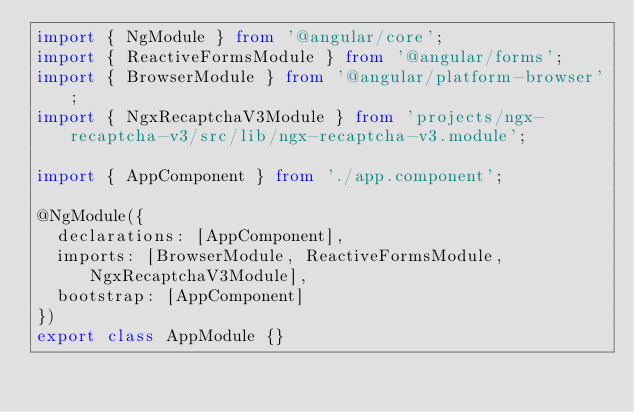Convert code to text. <code><loc_0><loc_0><loc_500><loc_500><_TypeScript_>import { NgModule } from '@angular/core';
import { ReactiveFormsModule } from '@angular/forms';
import { BrowserModule } from '@angular/platform-browser';
import { NgxRecaptchaV3Module } from 'projects/ngx-recaptcha-v3/src/lib/ngx-recaptcha-v3.module';

import { AppComponent } from './app.component';

@NgModule({
  declarations: [AppComponent],
  imports: [BrowserModule, ReactiveFormsModule, NgxRecaptchaV3Module],
  bootstrap: [AppComponent]
})
export class AppModule {}
</code> 